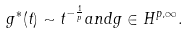Convert formula to latex. <formula><loc_0><loc_0><loc_500><loc_500>g ^ { * } ( t ) \sim t ^ { - \frac { 1 } { p } } a n d g \in H ^ { p , \infty } .</formula> 